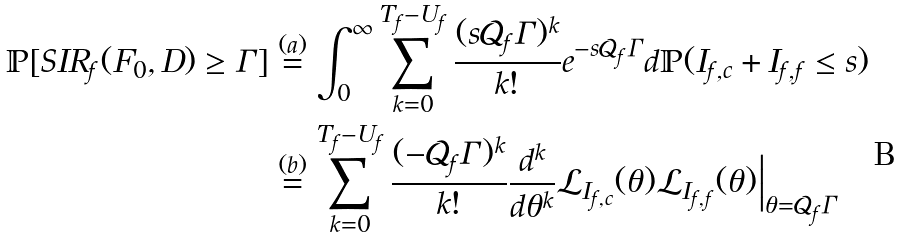<formula> <loc_0><loc_0><loc_500><loc_500>\mathbb { P } { [ S I R _ { f } ( F _ { 0 } , D ) \geq \Gamma ] } & \overset { ( a ) } = \int _ { 0 } ^ { \infty } \sum _ { k = 0 } ^ { T _ { f } - U _ { f } } \frac { ( s \mathcal { Q } _ { f } \Gamma ) ^ { k } } { k ! } e ^ { - s \mathcal { Q } _ { f } \Gamma } d \mathbb { P } { ( I _ { f , c } + I _ { f , f } \leq s ) } \\ & \overset { ( b ) } = \sum _ { k = 0 } ^ { T _ { f } - U _ { f } } \frac { ( - \mathcal { Q } _ { f } \Gamma ) ^ { k } } { k ! } \frac { d ^ { k } } { d \theta ^ { k } } \mathcal { L } _ { I _ { f , c } } ( \theta ) \mathcal { L } _ { I _ { f , f } } ( \theta ) \Big | _ { \theta = \mathcal { Q } _ { f } \Gamma }</formula> 